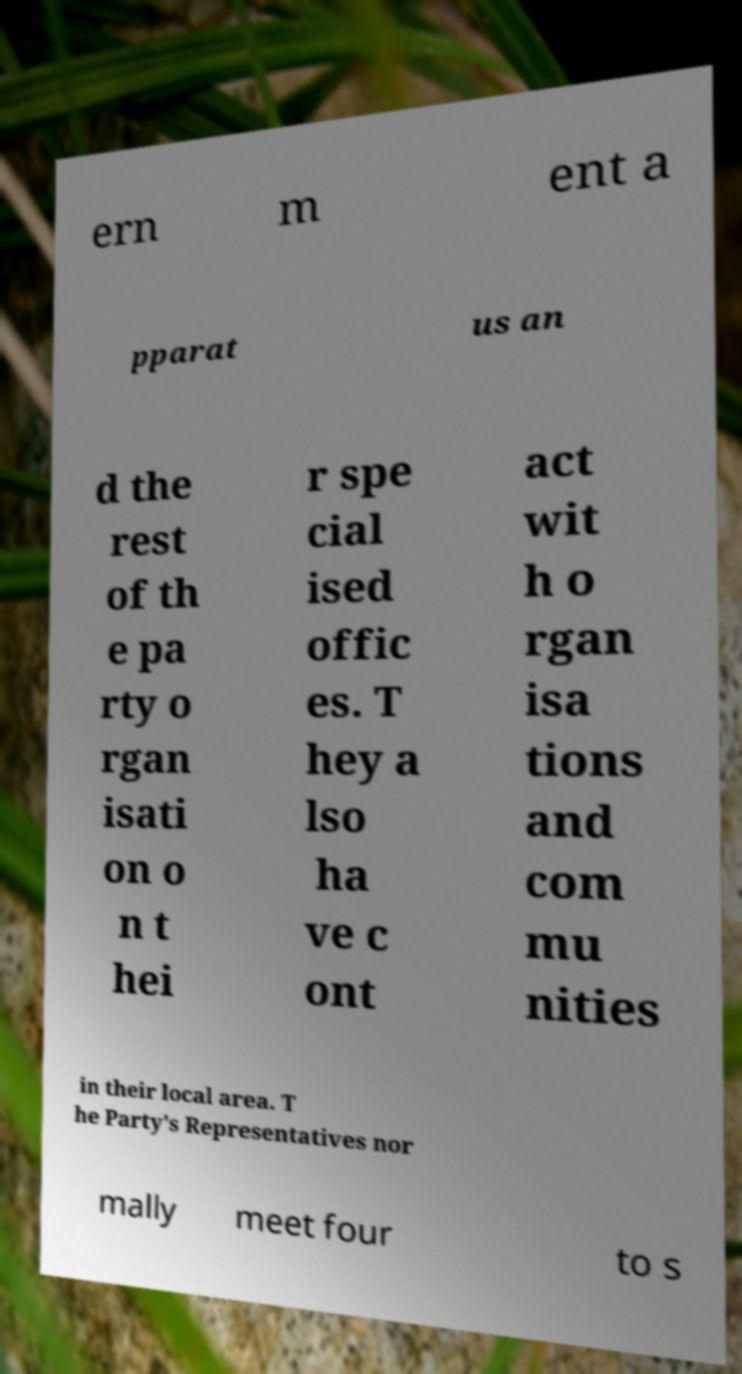Can you read and provide the text displayed in the image?This photo seems to have some interesting text. Can you extract and type it out for me? ern m ent a pparat us an d the rest of th e pa rty o rgan isati on o n t hei r spe cial ised offic es. T hey a lso ha ve c ont act wit h o rgan isa tions and com mu nities in their local area. T he Party's Representatives nor mally meet four to s 